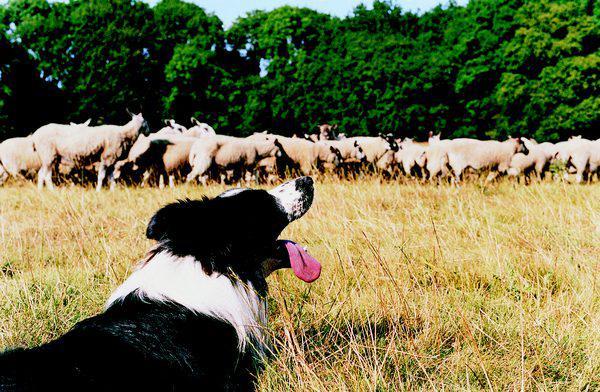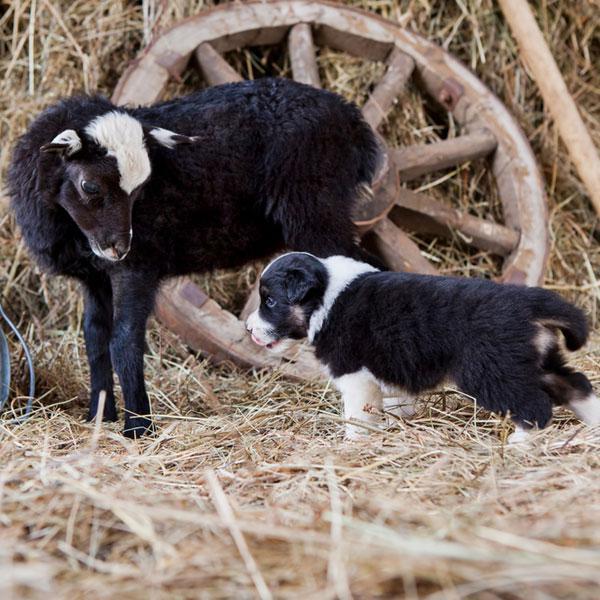The first image is the image on the left, the second image is the image on the right. For the images displayed, is the sentence "An image shows one dog in foreground facing a mass of sheep at the rear of image." factually correct? Answer yes or no. Yes. The first image is the image on the left, the second image is the image on the right. Considering the images on both sides, is "One of the images shows exactly one dog with one sheep." valid? Answer yes or no. Yes. 